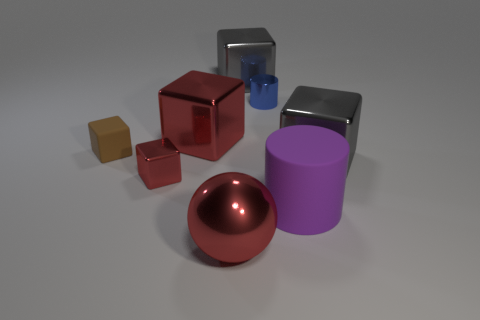Subtract all metallic cubes. How many cubes are left? 1 Add 2 yellow cylinders. How many objects exist? 10 Subtract 1 balls. How many balls are left? 0 Subtract all brown blocks. How many blocks are left? 4 Subtract all spheres. How many objects are left? 7 Subtract all blue cylinders. How many brown cubes are left? 1 Add 1 large gray blocks. How many large gray blocks exist? 3 Subtract 2 gray blocks. How many objects are left? 6 Subtract all green blocks. Subtract all blue balls. How many blocks are left? 5 Subtract all small purple cylinders. Subtract all big blocks. How many objects are left? 5 